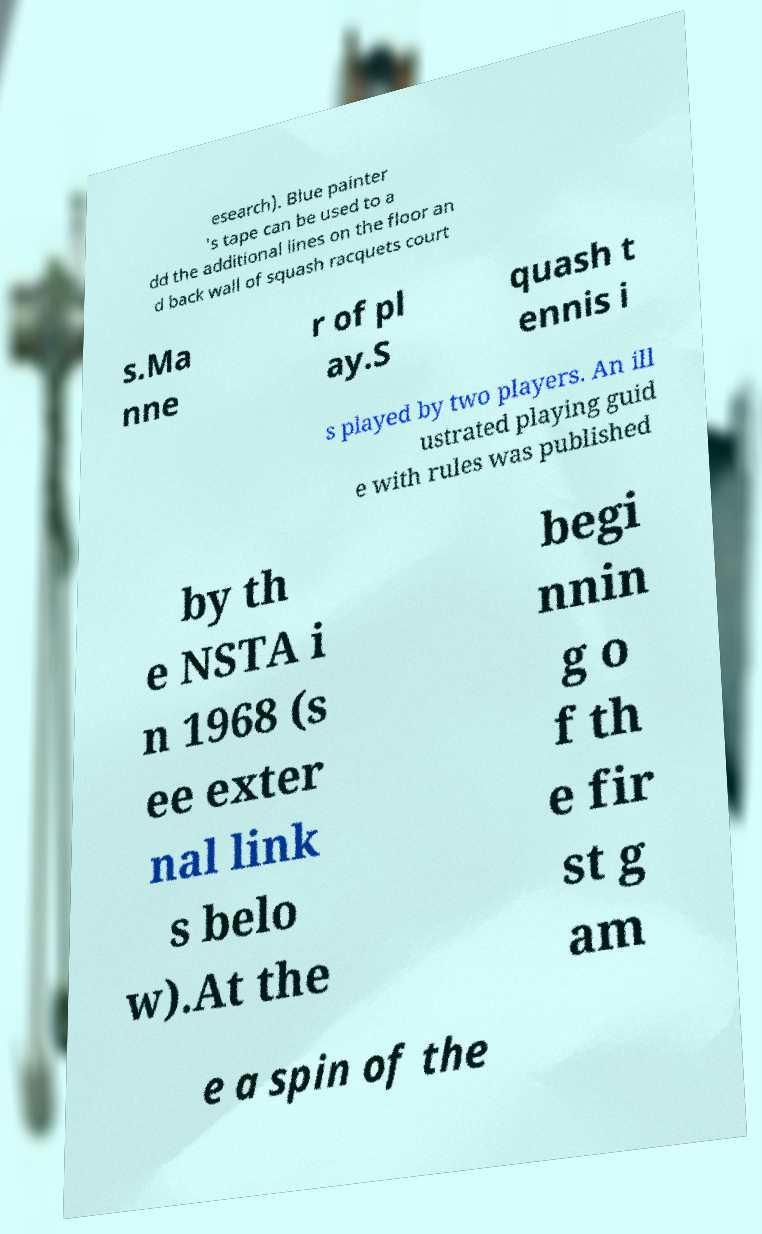Could you extract and type out the text from this image? esearch). Blue painter 's tape can be used to a dd the additional lines on the floor an d back wall of squash racquets court s.Ma nne r of pl ay.S quash t ennis i s played by two players. An ill ustrated playing guid e with rules was published by th e NSTA i n 1968 (s ee exter nal link s belo w).At the begi nnin g o f th e fir st g am e a spin of the 